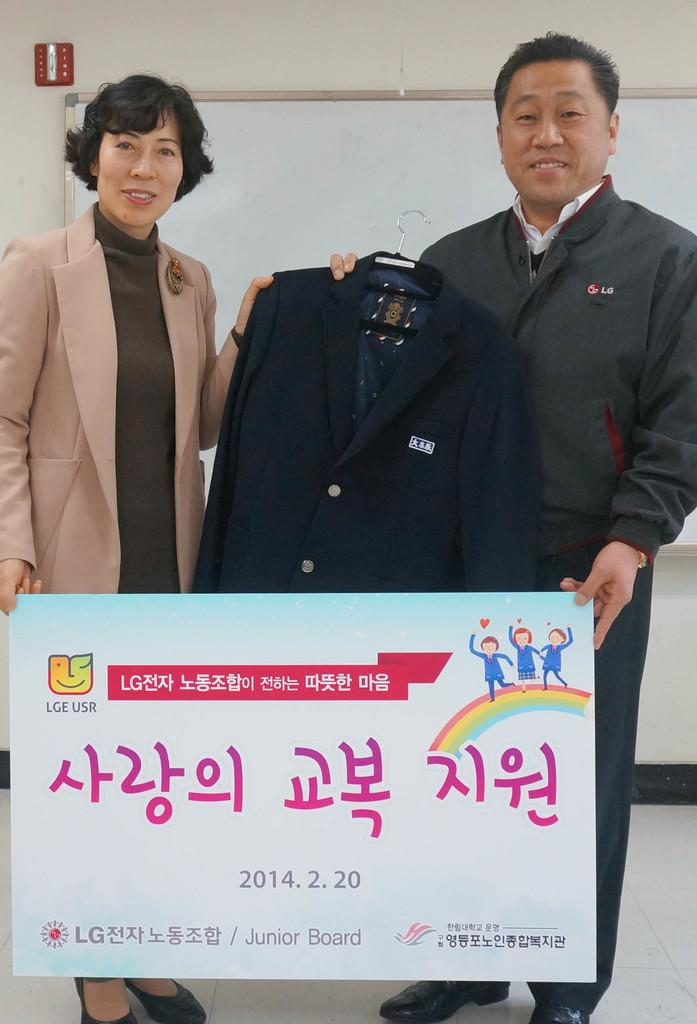How many people are present in the image? There is a man and a woman present in the image. What are the man and woman holding in the image? The man and woman are holding a board in the image. What else can be seen in the image besides the man and woman? There is a coat with a hanger in the image. What is visible on the backside of the image? There is a board and a wall visible on the backside of the image. What type of pet can be seen in the image? There is no pet visible in the image. What scene is being depicted in the image? The image does not depict a specific scene; it simply shows a man and a woman holding a board. 